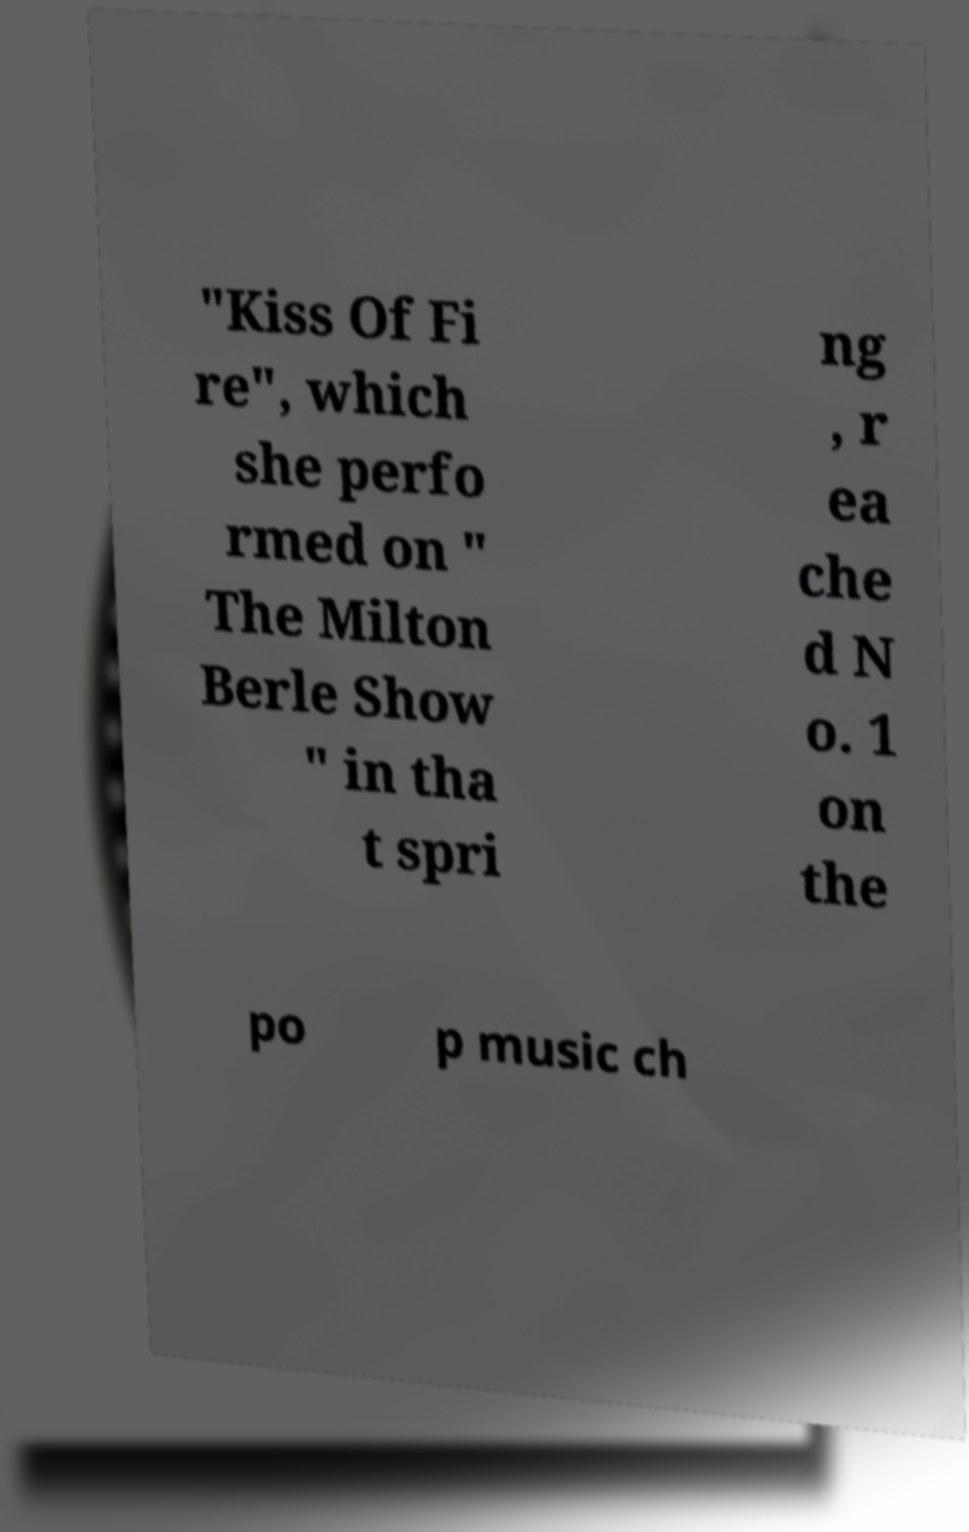There's text embedded in this image that I need extracted. Can you transcribe it verbatim? "Kiss Of Fi re", which she perfo rmed on " The Milton Berle Show " in tha t spri ng , r ea che d N o. 1 on the po p music ch 